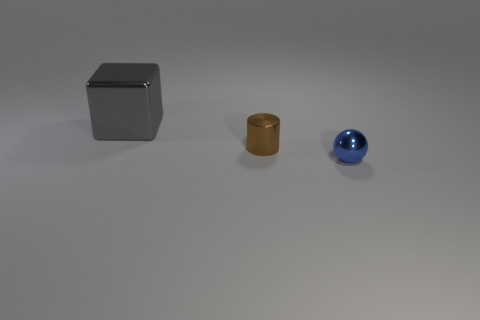Are there any large things right of the ball?
Your answer should be compact. No. There is a tiny thing that is behind the small thing on the right side of the small metal object to the left of the small blue sphere; what is its color?
Your response must be concise. Brown. Is the blue metallic thing the same shape as the brown thing?
Provide a short and direct response. No. What is the color of the tiny cylinder that is made of the same material as the small blue thing?
Offer a very short reply. Brown. How many things are either tiny objects that are left of the tiny blue sphere or big metallic blocks?
Your response must be concise. 2. What is the size of the metallic thing in front of the brown thing?
Your answer should be compact. Small. Does the blue metal thing have the same size as the thing to the left of the brown shiny cylinder?
Provide a succinct answer. No. The thing left of the small thing that is left of the tiny blue sphere is what color?
Your answer should be compact. Gray. How many other things are there of the same color as the large cube?
Make the answer very short. 0. What size is the metal cylinder?
Provide a succinct answer. Small. 